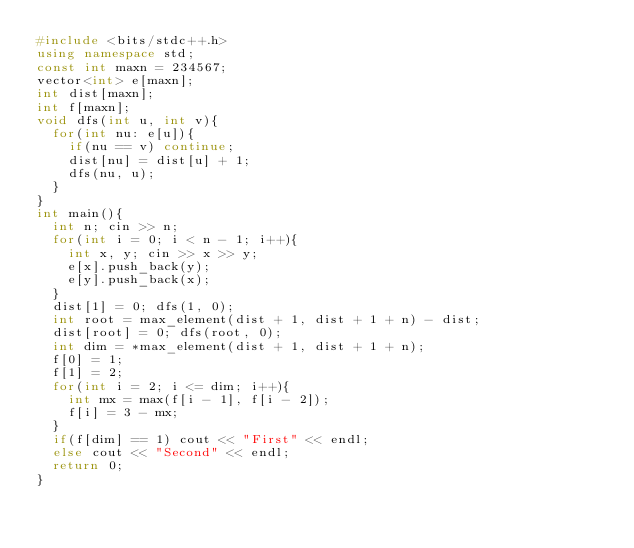<code> <loc_0><loc_0><loc_500><loc_500><_C++_>#include <bits/stdc++.h>
using namespace std;
const int maxn = 234567;
vector<int> e[maxn];
int dist[maxn];
int f[maxn];
void dfs(int u, int v){
	for(int nu: e[u]){
		if(nu == v) continue;
		dist[nu] = dist[u] + 1;
		dfs(nu, u);
	}
}
int main(){
	int n; cin >> n;
	for(int i = 0; i < n - 1; i++){
		int x, y; cin >> x >> y;
		e[x].push_back(y);
		e[y].push_back(x);
	}
	dist[1] = 0; dfs(1, 0);
	int root = max_element(dist + 1, dist + 1 + n) - dist;
	dist[root] = 0; dfs(root, 0);
	int dim = *max_element(dist + 1, dist + 1 + n);
	f[0] = 1;
	f[1] = 2;
	for(int i = 2; i <= dim; i++){
		int mx = max(f[i - 1], f[i - 2]);
		f[i] = 3 - mx;
	}
	if(f[dim] == 1) cout << "First" << endl;
	else cout << "Second" << endl;
	return 0;
}
</code> 